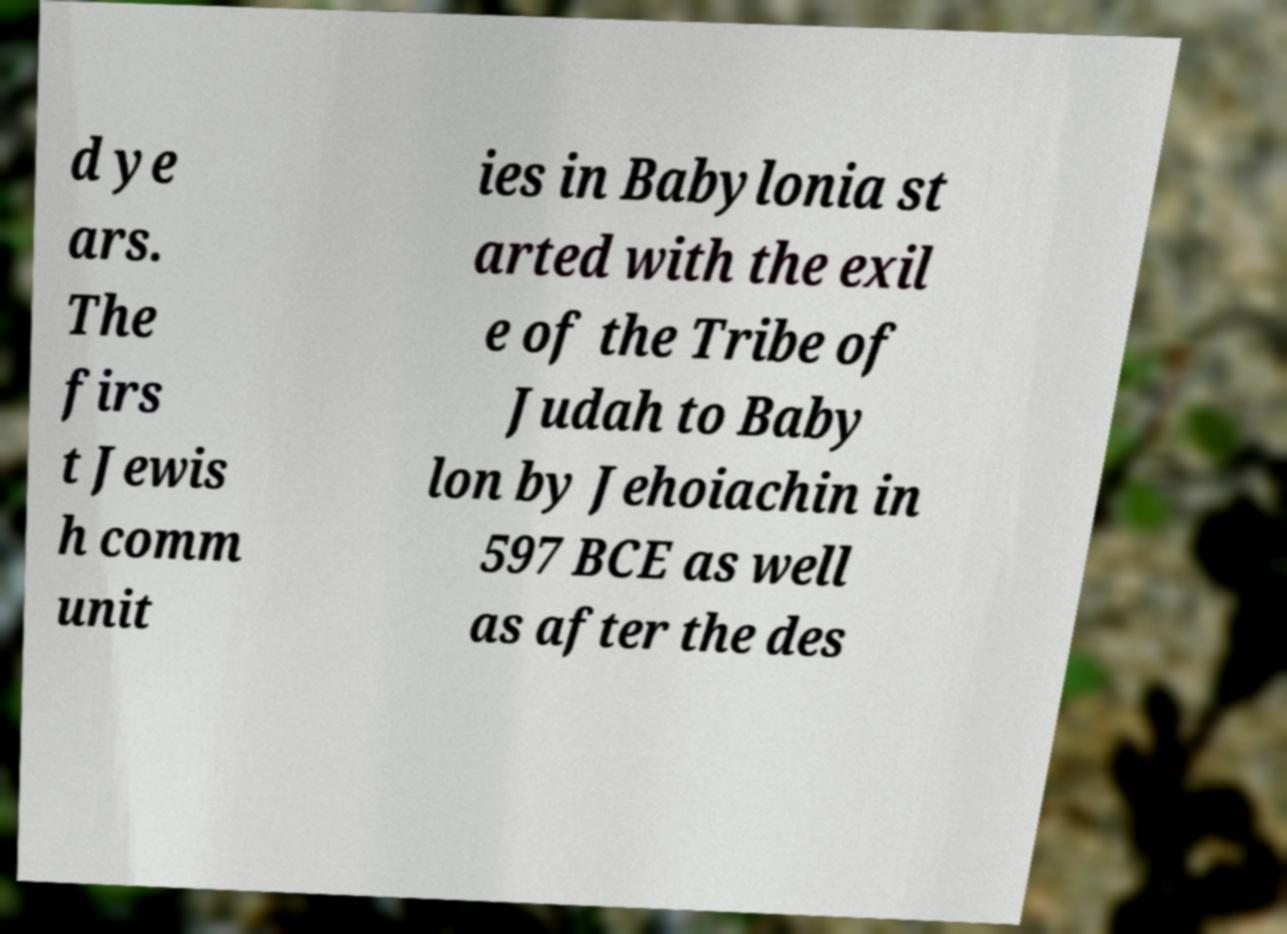What messages or text are displayed in this image? I need them in a readable, typed format. d ye ars. The firs t Jewis h comm unit ies in Babylonia st arted with the exil e of the Tribe of Judah to Baby lon by Jehoiachin in 597 BCE as well as after the des 